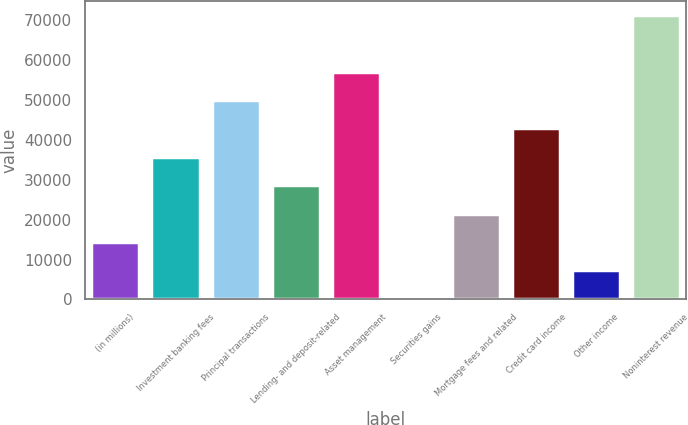Convert chart. <chart><loc_0><loc_0><loc_500><loc_500><bar_chart><fcel>(in millions)<fcel>Investment banking fees<fcel>Principal transactions<fcel>Lending- and deposit-related<fcel>Asset management<fcel>Securities gains<fcel>Mortgage fees and related<fcel>Credit card income<fcel>Other income<fcel>Noninterest revenue<nl><fcel>14405.6<fcel>35768<fcel>50009.6<fcel>28647.2<fcel>57130.4<fcel>164<fcel>21526.4<fcel>42888.8<fcel>7284.8<fcel>71372<nl></chart> 